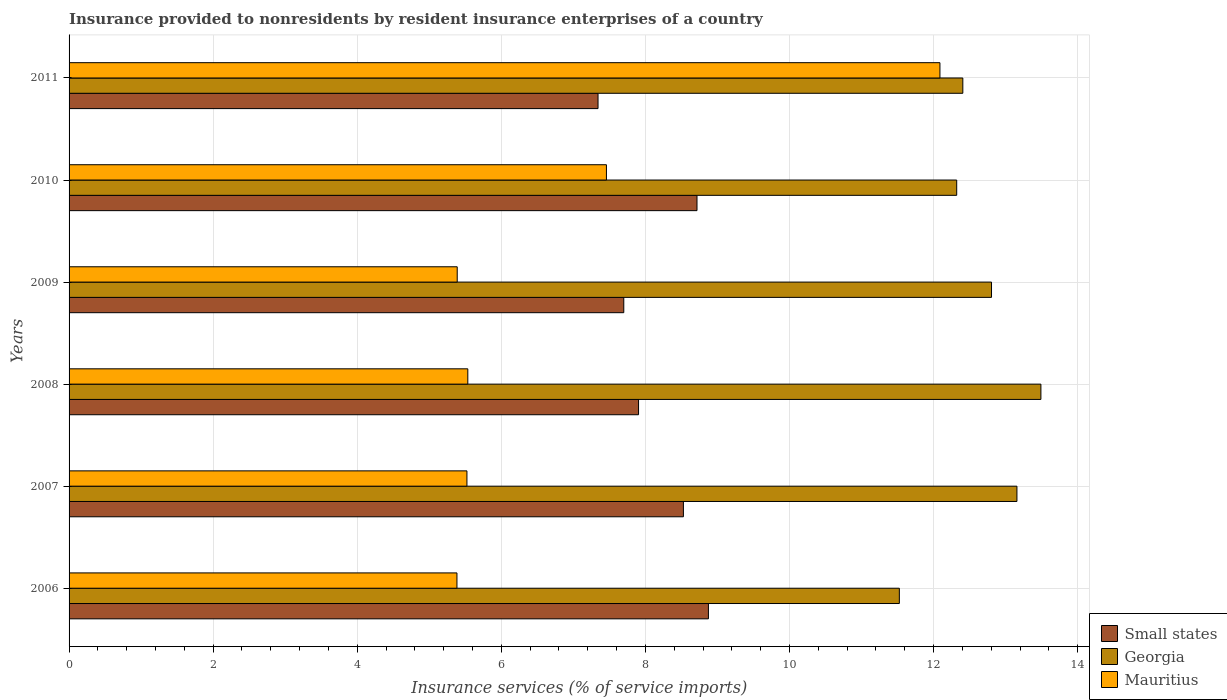Are the number of bars per tick equal to the number of legend labels?
Make the answer very short. Yes. Are the number of bars on each tick of the Y-axis equal?
Make the answer very short. Yes. How many bars are there on the 5th tick from the top?
Your answer should be compact. 3. How many bars are there on the 6th tick from the bottom?
Your answer should be very brief. 3. In how many cases, is the number of bars for a given year not equal to the number of legend labels?
Give a very brief answer. 0. What is the insurance provided to nonresidents in Small states in 2007?
Your response must be concise. 8.53. Across all years, what is the maximum insurance provided to nonresidents in Small states?
Your answer should be compact. 8.87. Across all years, what is the minimum insurance provided to nonresidents in Georgia?
Offer a terse response. 11.53. In which year was the insurance provided to nonresidents in Georgia maximum?
Offer a very short reply. 2008. In which year was the insurance provided to nonresidents in Small states minimum?
Provide a short and direct response. 2011. What is the total insurance provided to nonresidents in Small states in the graph?
Give a very brief answer. 49.07. What is the difference between the insurance provided to nonresidents in Georgia in 2006 and that in 2008?
Offer a very short reply. -1.96. What is the difference between the insurance provided to nonresidents in Small states in 2006 and the insurance provided to nonresidents in Mauritius in 2008?
Provide a short and direct response. 3.34. What is the average insurance provided to nonresidents in Georgia per year?
Your answer should be very brief. 12.62. In the year 2008, what is the difference between the insurance provided to nonresidents in Mauritius and insurance provided to nonresidents in Georgia?
Make the answer very short. -7.96. What is the ratio of the insurance provided to nonresidents in Small states in 2006 to that in 2008?
Offer a very short reply. 1.12. What is the difference between the highest and the second highest insurance provided to nonresidents in Mauritius?
Ensure brevity in your answer.  4.63. What is the difference between the highest and the lowest insurance provided to nonresidents in Small states?
Ensure brevity in your answer.  1.53. What does the 2nd bar from the top in 2009 represents?
Provide a succinct answer. Georgia. What does the 3rd bar from the bottom in 2009 represents?
Give a very brief answer. Mauritius. Is it the case that in every year, the sum of the insurance provided to nonresidents in Georgia and insurance provided to nonresidents in Mauritius is greater than the insurance provided to nonresidents in Small states?
Offer a terse response. Yes. How many bars are there?
Your answer should be compact. 18. Are all the bars in the graph horizontal?
Ensure brevity in your answer.  Yes. How many years are there in the graph?
Provide a short and direct response. 6. What is the difference between two consecutive major ticks on the X-axis?
Offer a very short reply. 2. Does the graph contain grids?
Provide a succinct answer. Yes. Where does the legend appear in the graph?
Your response must be concise. Bottom right. What is the title of the graph?
Offer a very short reply. Insurance provided to nonresidents by resident insurance enterprises of a country. Does "Caribbean small states" appear as one of the legend labels in the graph?
Ensure brevity in your answer.  No. What is the label or title of the X-axis?
Provide a succinct answer. Insurance services (% of service imports). What is the label or title of the Y-axis?
Give a very brief answer. Years. What is the Insurance services (% of service imports) in Small states in 2006?
Offer a very short reply. 8.87. What is the Insurance services (% of service imports) in Georgia in 2006?
Offer a terse response. 11.53. What is the Insurance services (% of service imports) in Mauritius in 2006?
Make the answer very short. 5.38. What is the Insurance services (% of service imports) in Small states in 2007?
Make the answer very short. 8.53. What is the Insurance services (% of service imports) of Georgia in 2007?
Your answer should be compact. 13.16. What is the Insurance services (% of service imports) of Mauritius in 2007?
Make the answer very short. 5.52. What is the Insurance services (% of service imports) of Small states in 2008?
Keep it short and to the point. 7.91. What is the Insurance services (% of service imports) of Georgia in 2008?
Keep it short and to the point. 13.49. What is the Insurance services (% of service imports) of Mauritius in 2008?
Your answer should be very brief. 5.53. What is the Insurance services (% of service imports) of Small states in 2009?
Provide a short and direct response. 7.7. What is the Insurance services (% of service imports) in Georgia in 2009?
Keep it short and to the point. 12.8. What is the Insurance services (% of service imports) of Mauritius in 2009?
Offer a very short reply. 5.39. What is the Insurance services (% of service imports) in Small states in 2010?
Your answer should be compact. 8.72. What is the Insurance services (% of service imports) in Georgia in 2010?
Make the answer very short. 12.32. What is the Insurance services (% of service imports) of Mauritius in 2010?
Your answer should be very brief. 7.46. What is the Insurance services (% of service imports) of Small states in 2011?
Offer a terse response. 7.34. What is the Insurance services (% of service imports) in Georgia in 2011?
Your answer should be very brief. 12.41. What is the Insurance services (% of service imports) of Mauritius in 2011?
Your response must be concise. 12.09. Across all years, what is the maximum Insurance services (% of service imports) of Small states?
Keep it short and to the point. 8.87. Across all years, what is the maximum Insurance services (% of service imports) in Georgia?
Ensure brevity in your answer.  13.49. Across all years, what is the maximum Insurance services (% of service imports) of Mauritius?
Your response must be concise. 12.09. Across all years, what is the minimum Insurance services (% of service imports) in Small states?
Your answer should be very brief. 7.34. Across all years, what is the minimum Insurance services (% of service imports) of Georgia?
Give a very brief answer. 11.53. Across all years, what is the minimum Insurance services (% of service imports) in Mauritius?
Offer a very short reply. 5.38. What is the total Insurance services (% of service imports) of Small states in the graph?
Ensure brevity in your answer.  49.07. What is the total Insurance services (% of service imports) of Georgia in the graph?
Offer a terse response. 75.7. What is the total Insurance services (% of service imports) of Mauritius in the graph?
Keep it short and to the point. 41.38. What is the difference between the Insurance services (% of service imports) of Small states in 2006 and that in 2007?
Give a very brief answer. 0.35. What is the difference between the Insurance services (% of service imports) in Georgia in 2006 and that in 2007?
Make the answer very short. -1.63. What is the difference between the Insurance services (% of service imports) of Mauritius in 2006 and that in 2007?
Provide a succinct answer. -0.14. What is the difference between the Insurance services (% of service imports) of Small states in 2006 and that in 2008?
Your answer should be compact. 0.97. What is the difference between the Insurance services (% of service imports) in Georgia in 2006 and that in 2008?
Make the answer very short. -1.96. What is the difference between the Insurance services (% of service imports) of Mauritius in 2006 and that in 2008?
Keep it short and to the point. -0.15. What is the difference between the Insurance services (% of service imports) of Small states in 2006 and that in 2009?
Offer a terse response. 1.17. What is the difference between the Insurance services (% of service imports) in Georgia in 2006 and that in 2009?
Provide a succinct answer. -1.28. What is the difference between the Insurance services (% of service imports) in Mauritius in 2006 and that in 2009?
Make the answer very short. -0. What is the difference between the Insurance services (% of service imports) in Small states in 2006 and that in 2010?
Provide a short and direct response. 0.16. What is the difference between the Insurance services (% of service imports) in Georgia in 2006 and that in 2010?
Provide a short and direct response. -0.8. What is the difference between the Insurance services (% of service imports) in Mauritius in 2006 and that in 2010?
Make the answer very short. -2.08. What is the difference between the Insurance services (% of service imports) in Small states in 2006 and that in 2011?
Give a very brief answer. 1.53. What is the difference between the Insurance services (% of service imports) in Georgia in 2006 and that in 2011?
Offer a very short reply. -0.88. What is the difference between the Insurance services (% of service imports) in Mauritius in 2006 and that in 2011?
Your answer should be compact. -6.7. What is the difference between the Insurance services (% of service imports) in Small states in 2007 and that in 2008?
Offer a terse response. 0.62. What is the difference between the Insurance services (% of service imports) of Georgia in 2007 and that in 2008?
Provide a succinct answer. -0.33. What is the difference between the Insurance services (% of service imports) of Mauritius in 2007 and that in 2008?
Your answer should be compact. -0.01. What is the difference between the Insurance services (% of service imports) of Small states in 2007 and that in 2009?
Your response must be concise. 0.83. What is the difference between the Insurance services (% of service imports) of Georgia in 2007 and that in 2009?
Make the answer very short. 0.35. What is the difference between the Insurance services (% of service imports) in Mauritius in 2007 and that in 2009?
Provide a short and direct response. 0.14. What is the difference between the Insurance services (% of service imports) in Small states in 2007 and that in 2010?
Your answer should be compact. -0.19. What is the difference between the Insurance services (% of service imports) of Georgia in 2007 and that in 2010?
Keep it short and to the point. 0.84. What is the difference between the Insurance services (% of service imports) in Mauritius in 2007 and that in 2010?
Your answer should be very brief. -1.94. What is the difference between the Insurance services (% of service imports) in Small states in 2007 and that in 2011?
Offer a terse response. 1.19. What is the difference between the Insurance services (% of service imports) in Georgia in 2007 and that in 2011?
Your answer should be compact. 0.75. What is the difference between the Insurance services (% of service imports) of Mauritius in 2007 and that in 2011?
Provide a short and direct response. -6.57. What is the difference between the Insurance services (% of service imports) in Small states in 2008 and that in 2009?
Give a very brief answer. 0.2. What is the difference between the Insurance services (% of service imports) in Georgia in 2008 and that in 2009?
Keep it short and to the point. 0.69. What is the difference between the Insurance services (% of service imports) in Mauritius in 2008 and that in 2009?
Your answer should be very brief. 0.15. What is the difference between the Insurance services (% of service imports) in Small states in 2008 and that in 2010?
Your answer should be very brief. -0.81. What is the difference between the Insurance services (% of service imports) of Georgia in 2008 and that in 2010?
Your answer should be compact. 1.17. What is the difference between the Insurance services (% of service imports) in Mauritius in 2008 and that in 2010?
Keep it short and to the point. -1.92. What is the difference between the Insurance services (% of service imports) in Small states in 2008 and that in 2011?
Offer a very short reply. 0.56. What is the difference between the Insurance services (% of service imports) in Georgia in 2008 and that in 2011?
Provide a succinct answer. 1.08. What is the difference between the Insurance services (% of service imports) of Mauritius in 2008 and that in 2011?
Offer a very short reply. -6.55. What is the difference between the Insurance services (% of service imports) in Small states in 2009 and that in 2010?
Provide a succinct answer. -1.02. What is the difference between the Insurance services (% of service imports) of Georgia in 2009 and that in 2010?
Offer a very short reply. 0.48. What is the difference between the Insurance services (% of service imports) of Mauritius in 2009 and that in 2010?
Ensure brevity in your answer.  -2.07. What is the difference between the Insurance services (% of service imports) in Small states in 2009 and that in 2011?
Provide a short and direct response. 0.36. What is the difference between the Insurance services (% of service imports) of Georgia in 2009 and that in 2011?
Your answer should be compact. 0.4. What is the difference between the Insurance services (% of service imports) of Mauritius in 2009 and that in 2011?
Ensure brevity in your answer.  -6.7. What is the difference between the Insurance services (% of service imports) in Small states in 2010 and that in 2011?
Keep it short and to the point. 1.37. What is the difference between the Insurance services (% of service imports) in Georgia in 2010 and that in 2011?
Offer a terse response. -0.09. What is the difference between the Insurance services (% of service imports) in Mauritius in 2010 and that in 2011?
Your response must be concise. -4.63. What is the difference between the Insurance services (% of service imports) of Small states in 2006 and the Insurance services (% of service imports) of Georgia in 2007?
Your answer should be compact. -4.28. What is the difference between the Insurance services (% of service imports) of Small states in 2006 and the Insurance services (% of service imports) of Mauritius in 2007?
Offer a terse response. 3.35. What is the difference between the Insurance services (% of service imports) of Georgia in 2006 and the Insurance services (% of service imports) of Mauritius in 2007?
Offer a very short reply. 6. What is the difference between the Insurance services (% of service imports) of Small states in 2006 and the Insurance services (% of service imports) of Georgia in 2008?
Make the answer very short. -4.62. What is the difference between the Insurance services (% of service imports) of Small states in 2006 and the Insurance services (% of service imports) of Mauritius in 2008?
Provide a succinct answer. 3.34. What is the difference between the Insurance services (% of service imports) in Georgia in 2006 and the Insurance services (% of service imports) in Mauritius in 2008?
Make the answer very short. 5.99. What is the difference between the Insurance services (% of service imports) of Small states in 2006 and the Insurance services (% of service imports) of Georgia in 2009?
Make the answer very short. -3.93. What is the difference between the Insurance services (% of service imports) of Small states in 2006 and the Insurance services (% of service imports) of Mauritius in 2009?
Ensure brevity in your answer.  3.49. What is the difference between the Insurance services (% of service imports) in Georgia in 2006 and the Insurance services (% of service imports) in Mauritius in 2009?
Your response must be concise. 6.14. What is the difference between the Insurance services (% of service imports) in Small states in 2006 and the Insurance services (% of service imports) in Georgia in 2010?
Your answer should be compact. -3.45. What is the difference between the Insurance services (% of service imports) in Small states in 2006 and the Insurance services (% of service imports) in Mauritius in 2010?
Give a very brief answer. 1.42. What is the difference between the Insurance services (% of service imports) in Georgia in 2006 and the Insurance services (% of service imports) in Mauritius in 2010?
Provide a succinct answer. 4.07. What is the difference between the Insurance services (% of service imports) in Small states in 2006 and the Insurance services (% of service imports) in Georgia in 2011?
Give a very brief answer. -3.53. What is the difference between the Insurance services (% of service imports) in Small states in 2006 and the Insurance services (% of service imports) in Mauritius in 2011?
Keep it short and to the point. -3.21. What is the difference between the Insurance services (% of service imports) of Georgia in 2006 and the Insurance services (% of service imports) of Mauritius in 2011?
Your answer should be very brief. -0.56. What is the difference between the Insurance services (% of service imports) of Small states in 2007 and the Insurance services (% of service imports) of Georgia in 2008?
Provide a succinct answer. -4.96. What is the difference between the Insurance services (% of service imports) in Small states in 2007 and the Insurance services (% of service imports) in Mauritius in 2008?
Your answer should be very brief. 2.99. What is the difference between the Insurance services (% of service imports) of Georgia in 2007 and the Insurance services (% of service imports) of Mauritius in 2008?
Provide a succinct answer. 7.62. What is the difference between the Insurance services (% of service imports) in Small states in 2007 and the Insurance services (% of service imports) in Georgia in 2009?
Ensure brevity in your answer.  -4.28. What is the difference between the Insurance services (% of service imports) of Small states in 2007 and the Insurance services (% of service imports) of Mauritius in 2009?
Provide a succinct answer. 3.14. What is the difference between the Insurance services (% of service imports) of Georgia in 2007 and the Insurance services (% of service imports) of Mauritius in 2009?
Provide a succinct answer. 7.77. What is the difference between the Insurance services (% of service imports) in Small states in 2007 and the Insurance services (% of service imports) in Georgia in 2010?
Ensure brevity in your answer.  -3.79. What is the difference between the Insurance services (% of service imports) of Small states in 2007 and the Insurance services (% of service imports) of Mauritius in 2010?
Make the answer very short. 1.07. What is the difference between the Insurance services (% of service imports) of Georgia in 2007 and the Insurance services (% of service imports) of Mauritius in 2010?
Provide a succinct answer. 5.7. What is the difference between the Insurance services (% of service imports) in Small states in 2007 and the Insurance services (% of service imports) in Georgia in 2011?
Ensure brevity in your answer.  -3.88. What is the difference between the Insurance services (% of service imports) of Small states in 2007 and the Insurance services (% of service imports) of Mauritius in 2011?
Give a very brief answer. -3.56. What is the difference between the Insurance services (% of service imports) of Georgia in 2007 and the Insurance services (% of service imports) of Mauritius in 2011?
Provide a short and direct response. 1.07. What is the difference between the Insurance services (% of service imports) of Small states in 2008 and the Insurance services (% of service imports) of Georgia in 2009?
Give a very brief answer. -4.9. What is the difference between the Insurance services (% of service imports) in Small states in 2008 and the Insurance services (% of service imports) in Mauritius in 2009?
Offer a terse response. 2.52. What is the difference between the Insurance services (% of service imports) in Georgia in 2008 and the Insurance services (% of service imports) in Mauritius in 2009?
Keep it short and to the point. 8.1. What is the difference between the Insurance services (% of service imports) of Small states in 2008 and the Insurance services (% of service imports) of Georgia in 2010?
Provide a short and direct response. -4.42. What is the difference between the Insurance services (% of service imports) of Small states in 2008 and the Insurance services (% of service imports) of Mauritius in 2010?
Ensure brevity in your answer.  0.45. What is the difference between the Insurance services (% of service imports) of Georgia in 2008 and the Insurance services (% of service imports) of Mauritius in 2010?
Ensure brevity in your answer.  6.03. What is the difference between the Insurance services (% of service imports) of Small states in 2008 and the Insurance services (% of service imports) of Georgia in 2011?
Offer a very short reply. -4.5. What is the difference between the Insurance services (% of service imports) in Small states in 2008 and the Insurance services (% of service imports) in Mauritius in 2011?
Offer a very short reply. -4.18. What is the difference between the Insurance services (% of service imports) in Georgia in 2008 and the Insurance services (% of service imports) in Mauritius in 2011?
Your response must be concise. 1.4. What is the difference between the Insurance services (% of service imports) in Small states in 2009 and the Insurance services (% of service imports) in Georgia in 2010?
Your answer should be compact. -4.62. What is the difference between the Insurance services (% of service imports) of Small states in 2009 and the Insurance services (% of service imports) of Mauritius in 2010?
Keep it short and to the point. 0.24. What is the difference between the Insurance services (% of service imports) of Georgia in 2009 and the Insurance services (% of service imports) of Mauritius in 2010?
Your response must be concise. 5.35. What is the difference between the Insurance services (% of service imports) in Small states in 2009 and the Insurance services (% of service imports) in Georgia in 2011?
Give a very brief answer. -4.71. What is the difference between the Insurance services (% of service imports) in Small states in 2009 and the Insurance services (% of service imports) in Mauritius in 2011?
Offer a terse response. -4.39. What is the difference between the Insurance services (% of service imports) of Georgia in 2009 and the Insurance services (% of service imports) of Mauritius in 2011?
Your answer should be very brief. 0.72. What is the difference between the Insurance services (% of service imports) of Small states in 2010 and the Insurance services (% of service imports) of Georgia in 2011?
Offer a terse response. -3.69. What is the difference between the Insurance services (% of service imports) in Small states in 2010 and the Insurance services (% of service imports) in Mauritius in 2011?
Your response must be concise. -3.37. What is the difference between the Insurance services (% of service imports) in Georgia in 2010 and the Insurance services (% of service imports) in Mauritius in 2011?
Make the answer very short. 0.23. What is the average Insurance services (% of service imports) of Small states per year?
Give a very brief answer. 8.18. What is the average Insurance services (% of service imports) in Georgia per year?
Ensure brevity in your answer.  12.62. What is the average Insurance services (% of service imports) in Mauritius per year?
Your response must be concise. 6.9. In the year 2006, what is the difference between the Insurance services (% of service imports) in Small states and Insurance services (% of service imports) in Georgia?
Provide a succinct answer. -2.65. In the year 2006, what is the difference between the Insurance services (% of service imports) of Small states and Insurance services (% of service imports) of Mauritius?
Provide a succinct answer. 3.49. In the year 2006, what is the difference between the Insurance services (% of service imports) in Georgia and Insurance services (% of service imports) in Mauritius?
Provide a succinct answer. 6.14. In the year 2007, what is the difference between the Insurance services (% of service imports) of Small states and Insurance services (% of service imports) of Georgia?
Offer a very short reply. -4.63. In the year 2007, what is the difference between the Insurance services (% of service imports) of Small states and Insurance services (% of service imports) of Mauritius?
Ensure brevity in your answer.  3. In the year 2007, what is the difference between the Insurance services (% of service imports) in Georgia and Insurance services (% of service imports) in Mauritius?
Your answer should be compact. 7.63. In the year 2008, what is the difference between the Insurance services (% of service imports) of Small states and Insurance services (% of service imports) of Georgia?
Keep it short and to the point. -5.58. In the year 2008, what is the difference between the Insurance services (% of service imports) in Small states and Insurance services (% of service imports) in Mauritius?
Give a very brief answer. 2.37. In the year 2008, what is the difference between the Insurance services (% of service imports) of Georgia and Insurance services (% of service imports) of Mauritius?
Ensure brevity in your answer.  7.96. In the year 2009, what is the difference between the Insurance services (% of service imports) in Small states and Insurance services (% of service imports) in Georgia?
Your answer should be compact. -5.1. In the year 2009, what is the difference between the Insurance services (% of service imports) of Small states and Insurance services (% of service imports) of Mauritius?
Keep it short and to the point. 2.31. In the year 2009, what is the difference between the Insurance services (% of service imports) in Georgia and Insurance services (% of service imports) in Mauritius?
Ensure brevity in your answer.  7.42. In the year 2010, what is the difference between the Insurance services (% of service imports) of Small states and Insurance services (% of service imports) of Georgia?
Make the answer very short. -3.6. In the year 2010, what is the difference between the Insurance services (% of service imports) of Small states and Insurance services (% of service imports) of Mauritius?
Make the answer very short. 1.26. In the year 2010, what is the difference between the Insurance services (% of service imports) in Georgia and Insurance services (% of service imports) in Mauritius?
Your answer should be compact. 4.86. In the year 2011, what is the difference between the Insurance services (% of service imports) in Small states and Insurance services (% of service imports) in Georgia?
Make the answer very short. -5.06. In the year 2011, what is the difference between the Insurance services (% of service imports) in Small states and Insurance services (% of service imports) in Mauritius?
Offer a very short reply. -4.75. In the year 2011, what is the difference between the Insurance services (% of service imports) in Georgia and Insurance services (% of service imports) in Mauritius?
Make the answer very short. 0.32. What is the ratio of the Insurance services (% of service imports) of Small states in 2006 to that in 2007?
Make the answer very short. 1.04. What is the ratio of the Insurance services (% of service imports) in Georgia in 2006 to that in 2007?
Your response must be concise. 0.88. What is the ratio of the Insurance services (% of service imports) of Mauritius in 2006 to that in 2007?
Your response must be concise. 0.97. What is the ratio of the Insurance services (% of service imports) in Small states in 2006 to that in 2008?
Give a very brief answer. 1.12. What is the ratio of the Insurance services (% of service imports) in Georgia in 2006 to that in 2008?
Provide a succinct answer. 0.85. What is the ratio of the Insurance services (% of service imports) in Mauritius in 2006 to that in 2008?
Keep it short and to the point. 0.97. What is the ratio of the Insurance services (% of service imports) of Small states in 2006 to that in 2009?
Provide a short and direct response. 1.15. What is the ratio of the Insurance services (% of service imports) of Georgia in 2006 to that in 2009?
Provide a short and direct response. 0.9. What is the ratio of the Insurance services (% of service imports) in Mauritius in 2006 to that in 2009?
Give a very brief answer. 1. What is the ratio of the Insurance services (% of service imports) of Small states in 2006 to that in 2010?
Give a very brief answer. 1.02. What is the ratio of the Insurance services (% of service imports) of Georgia in 2006 to that in 2010?
Offer a very short reply. 0.94. What is the ratio of the Insurance services (% of service imports) in Mauritius in 2006 to that in 2010?
Ensure brevity in your answer.  0.72. What is the ratio of the Insurance services (% of service imports) in Small states in 2006 to that in 2011?
Offer a terse response. 1.21. What is the ratio of the Insurance services (% of service imports) in Georgia in 2006 to that in 2011?
Make the answer very short. 0.93. What is the ratio of the Insurance services (% of service imports) in Mauritius in 2006 to that in 2011?
Your answer should be very brief. 0.45. What is the ratio of the Insurance services (% of service imports) in Small states in 2007 to that in 2008?
Give a very brief answer. 1.08. What is the ratio of the Insurance services (% of service imports) in Georgia in 2007 to that in 2008?
Ensure brevity in your answer.  0.98. What is the ratio of the Insurance services (% of service imports) in Small states in 2007 to that in 2009?
Offer a terse response. 1.11. What is the ratio of the Insurance services (% of service imports) of Georgia in 2007 to that in 2009?
Keep it short and to the point. 1.03. What is the ratio of the Insurance services (% of service imports) of Small states in 2007 to that in 2010?
Make the answer very short. 0.98. What is the ratio of the Insurance services (% of service imports) in Georgia in 2007 to that in 2010?
Provide a short and direct response. 1.07. What is the ratio of the Insurance services (% of service imports) in Mauritius in 2007 to that in 2010?
Provide a short and direct response. 0.74. What is the ratio of the Insurance services (% of service imports) in Small states in 2007 to that in 2011?
Offer a very short reply. 1.16. What is the ratio of the Insurance services (% of service imports) of Georgia in 2007 to that in 2011?
Provide a short and direct response. 1.06. What is the ratio of the Insurance services (% of service imports) in Mauritius in 2007 to that in 2011?
Your answer should be compact. 0.46. What is the ratio of the Insurance services (% of service imports) in Small states in 2008 to that in 2009?
Ensure brevity in your answer.  1.03. What is the ratio of the Insurance services (% of service imports) in Georgia in 2008 to that in 2009?
Offer a very short reply. 1.05. What is the ratio of the Insurance services (% of service imports) in Mauritius in 2008 to that in 2009?
Make the answer very short. 1.03. What is the ratio of the Insurance services (% of service imports) in Small states in 2008 to that in 2010?
Keep it short and to the point. 0.91. What is the ratio of the Insurance services (% of service imports) of Georgia in 2008 to that in 2010?
Make the answer very short. 1.09. What is the ratio of the Insurance services (% of service imports) of Mauritius in 2008 to that in 2010?
Give a very brief answer. 0.74. What is the ratio of the Insurance services (% of service imports) in Small states in 2008 to that in 2011?
Ensure brevity in your answer.  1.08. What is the ratio of the Insurance services (% of service imports) in Georgia in 2008 to that in 2011?
Make the answer very short. 1.09. What is the ratio of the Insurance services (% of service imports) of Mauritius in 2008 to that in 2011?
Your response must be concise. 0.46. What is the ratio of the Insurance services (% of service imports) of Small states in 2009 to that in 2010?
Ensure brevity in your answer.  0.88. What is the ratio of the Insurance services (% of service imports) of Georgia in 2009 to that in 2010?
Offer a terse response. 1.04. What is the ratio of the Insurance services (% of service imports) of Mauritius in 2009 to that in 2010?
Give a very brief answer. 0.72. What is the ratio of the Insurance services (% of service imports) of Small states in 2009 to that in 2011?
Provide a succinct answer. 1.05. What is the ratio of the Insurance services (% of service imports) of Georgia in 2009 to that in 2011?
Provide a short and direct response. 1.03. What is the ratio of the Insurance services (% of service imports) of Mauritius in 2009 to that in 2011?
Provide a succinct answer. 0.45. What is the ratio of the Insurance services (% of service imports) in Small states in 2010 to that in 2011?
Make the answer very short. 1.19. What is the ratio of the Insurance services (% of service imports) of Mauritius in 2010 to that in 2011?
Provide a short and direct response. 0.62. What is the difference between the highest and the second highest Insurance services (% of service imports) of Small states?
Keep it short and to the point. 0.16. What is the difference between the highest and the second highest Insurance services (% of service imports) in Georgia?
Offer a very short reply. 0.33. What is the difference between the highest and the second highest Insurance services (% of service imports) of Mauritius?
Give a very brief answer. 4.63. What is the difference between the highest and the lowest Insurance services (% of service imports) in Small states?
Your answer should be very brief. 1.53. What is the difference between the highest and the lowest Insurance services (% of service imports) of Georgia?
Your answer should be very brief. 1.96. What is the difference between the highest and the lowest Insurance services (% of service imports) in Mauritius?
Provide a short and direct response. 6.7. 